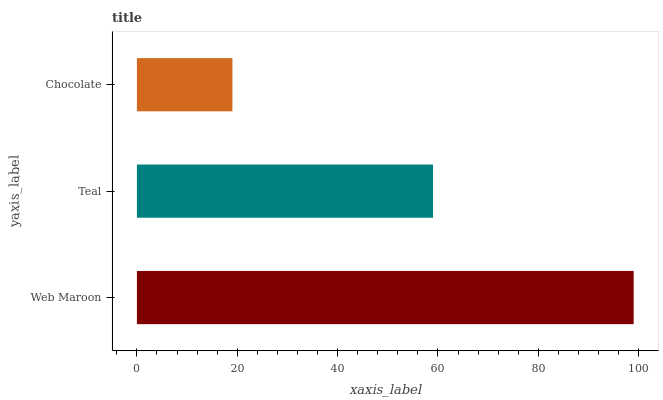Is Chocolate the minimum?
Answer yes or no. Yes. Is Web Maroon the maximum?
Answer yes or no. Yes. Is Teal the minimum?
Answer yes or no. No. Is Teal the maximum?
Answer yes or no. No. Is Web Maroon greater than Teal?
Answer yes or no. Yes. Is Teal less than Web Maroon?
Answer yes or no. Yes. Is Teal greater than Web Maroon?
Answer yes or no. No. Is Web Maroon less than Teal?
Answer yes or no. No. Is Teal the high median?
Answer yes or no. Yes. Is Teal the low median?
Answer yes or no. Yes. Is Web Maroon the high median?
Answer yes or no. No. Is Chocolate the low median?
Answer yes or no. No. 